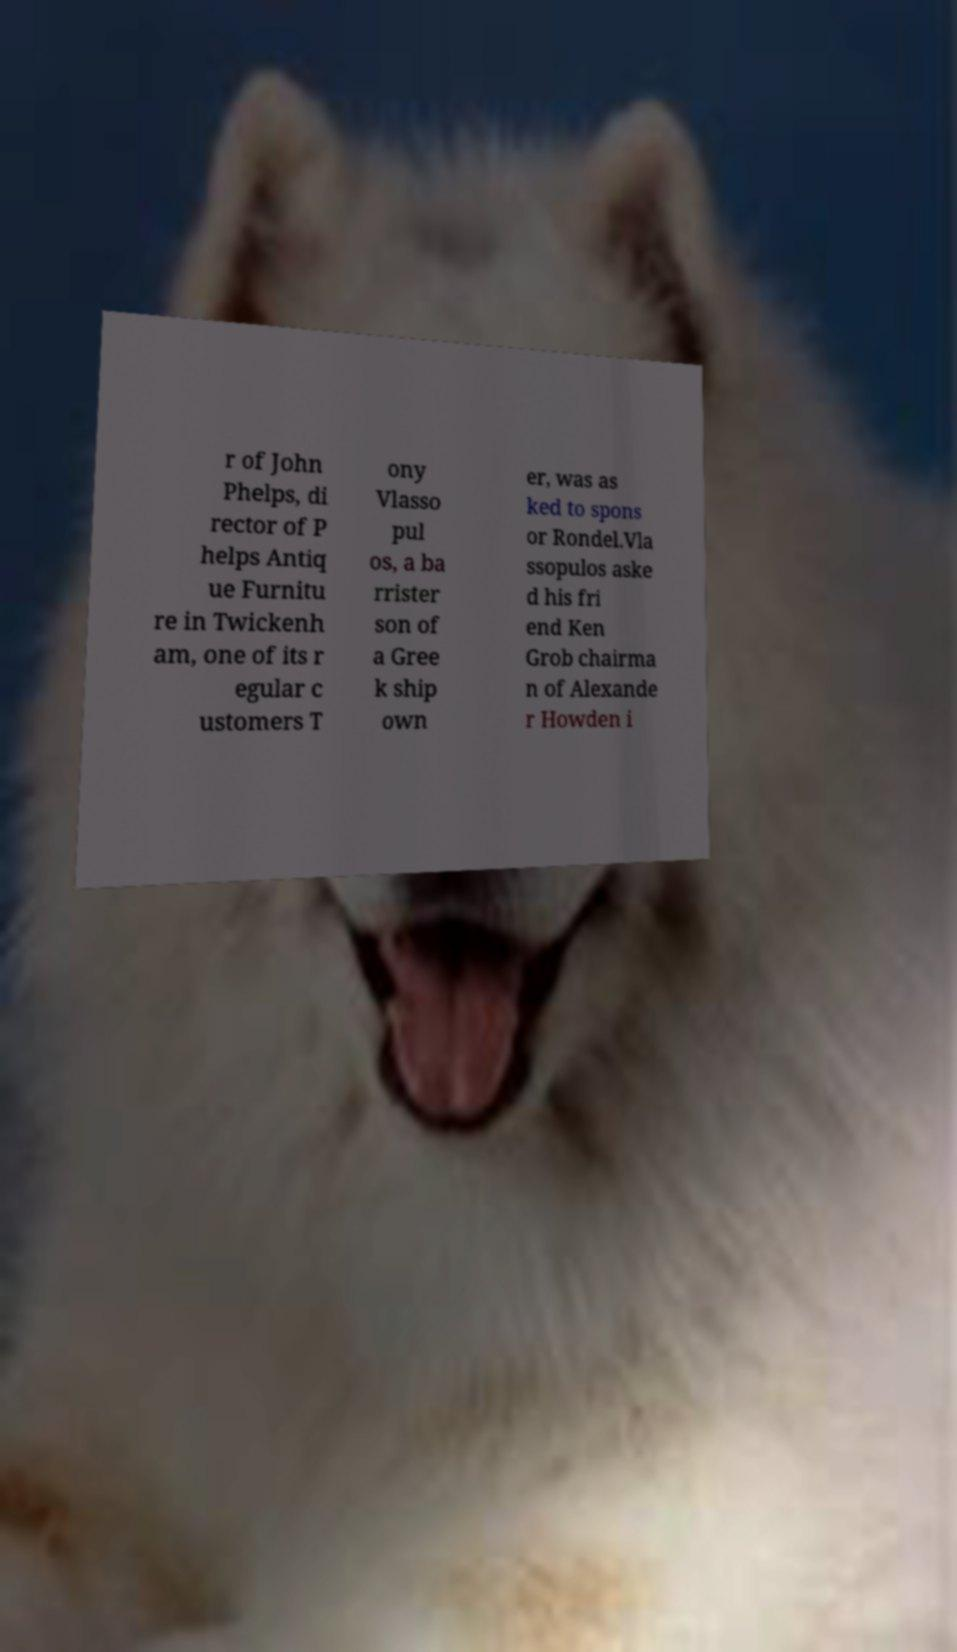What messages or text are displayed in this image? I need them in a readable, typed format. r of John Phelps, di rector of P helps Antiq ue Furnitu re in Twickenh am, one of its r egular c ustomers T ony Vlasso pul os, a ba rrister son of a Gree k ship own er, was as ked to spons or Rondel.Vla ssopulos aske d his fri end Ken Grob chairma n of Alexande r Howden i 